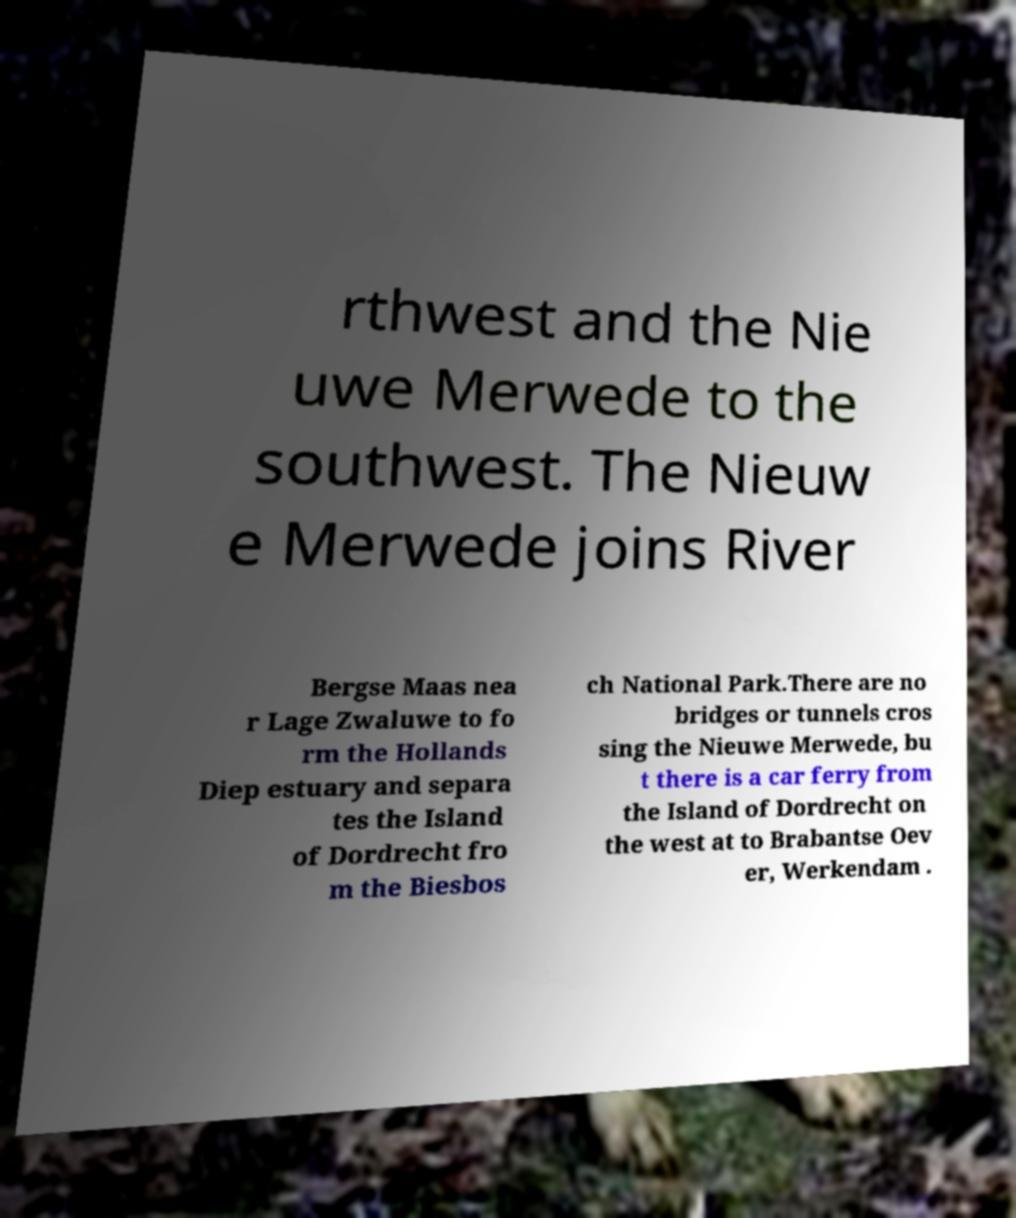Please identify and transcribe the text found in this image. rthwest and the Nie uwe Merwede to the southwest. The Nieuw e Merwede joins River Bergse Maas nea r Lage Zwaluwe to fo rm the Hollands Diep estuary and separa tes the Island of Dordrecht fro m the Biesbos ch National Park.There are no bridges or tunnels cros sing the Nieuwe Merwede, bu t there is a car ferry from the Island of Dordrecht on the west at to Brabantse Oev er, Werkendam . 